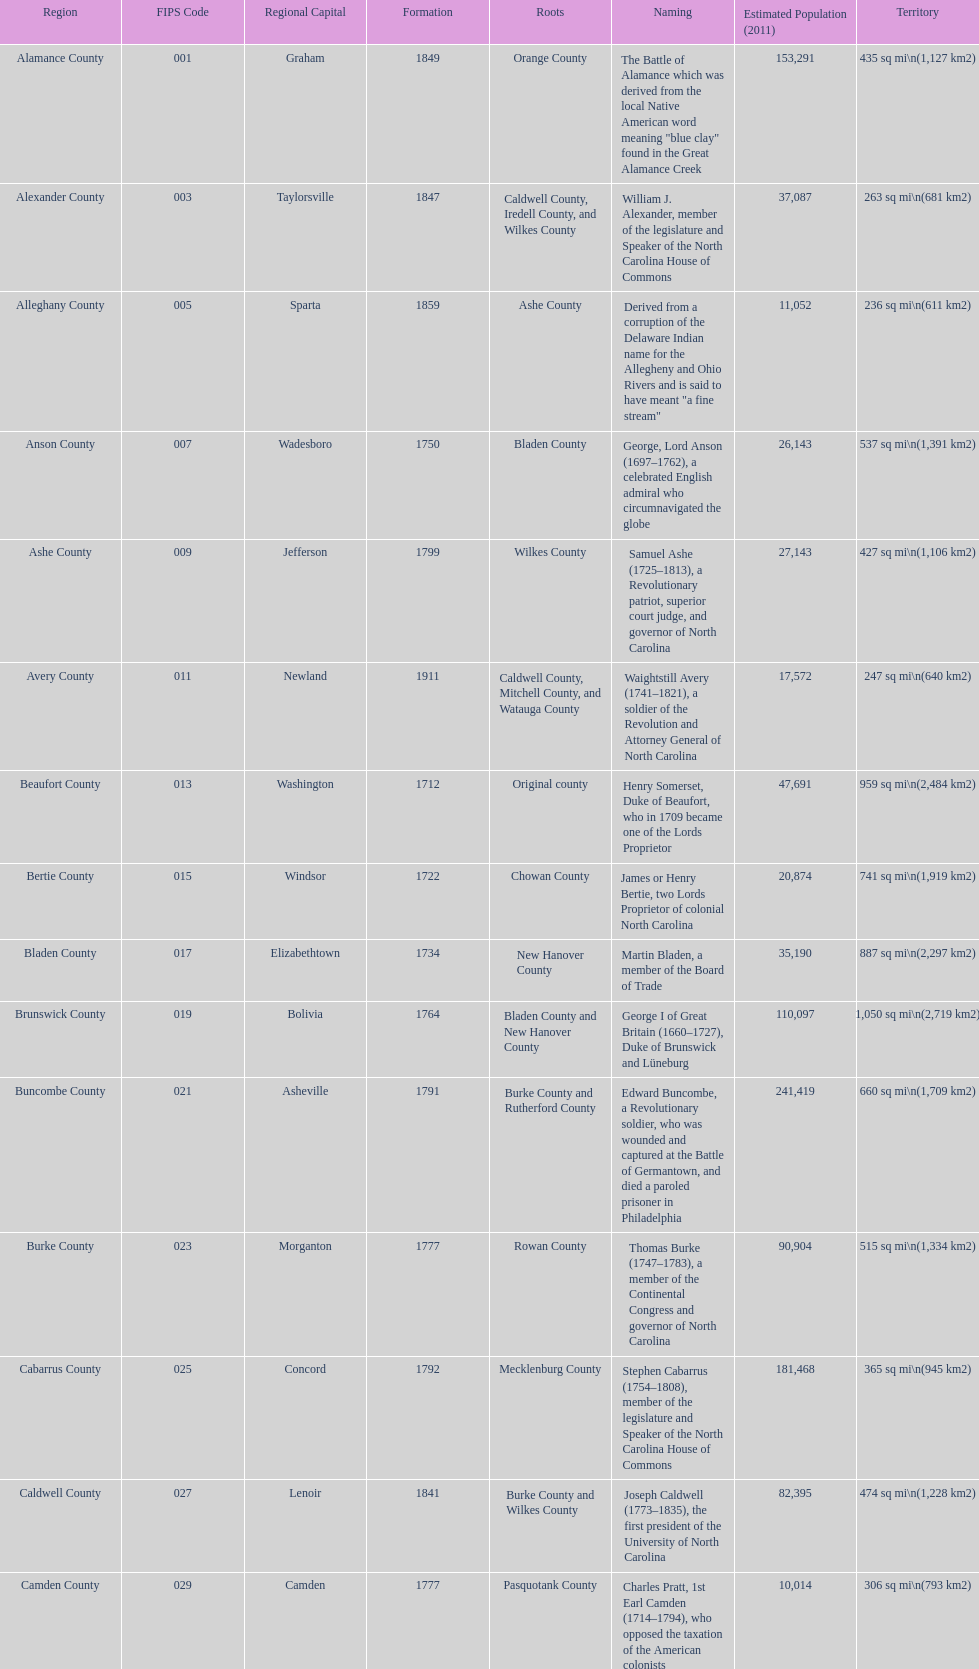What is the count of counties named in honor of us presidents? 3. 